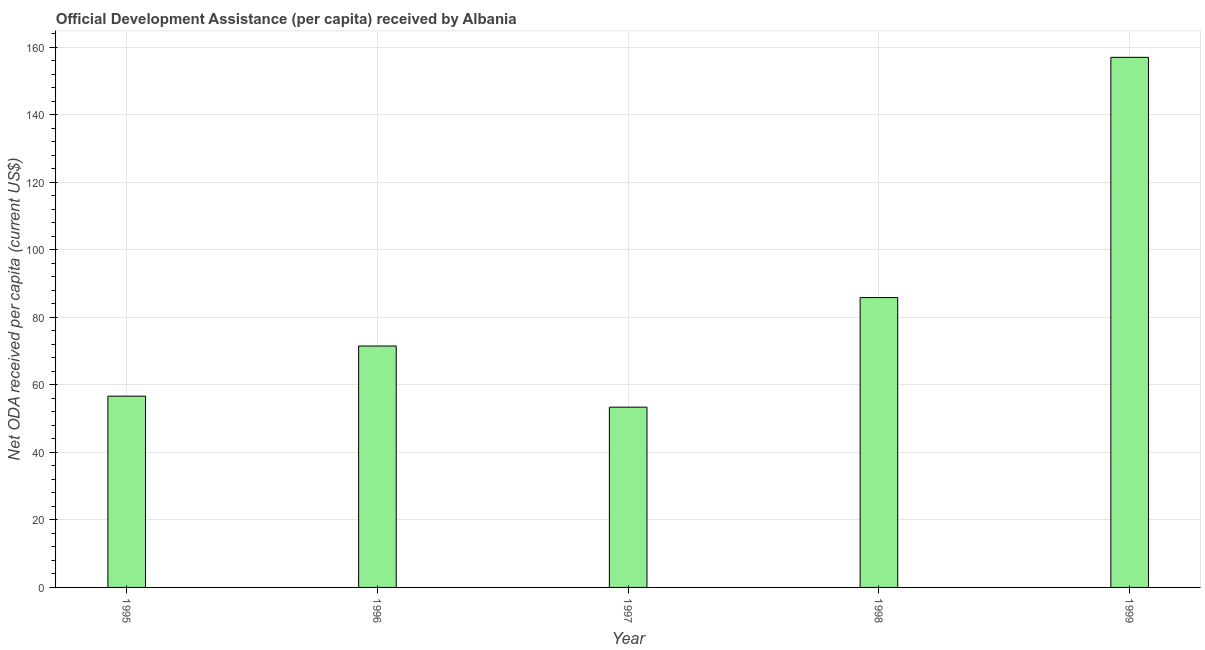Does the graph contain any zero values?
Your answer should be compact. No. Does the graph contain grids?
Your answer should be very brief. Yes. What is the title of the graph?
Provide a short and direct response. Official Development Assistance (per capita) received by Albania. What is the label or title of the X-axis?
Offer a very short reply. Year. What is the label or title of the Y-axis?
Provide a succinct answer. Net ODA received per capita (current US$). What is the net oda received per capita in 1997?
Your answer should be very brief. 53.4. Across all years, what is the maximum net oda received per capita?
Provide a succinct answer. 157.02. Across all years, what is the minimum net oda received per capita?
Keep it short and to the point. 53.4. In which year was the net oda received per capita maximum?
Your answer should be compact. 1999. In which year was the net oda received per capita minimum?
Offer a terse response. 1997. What is the sum of the net oda received per capita?
Give a very brief answer. 424.45. What is the difference between the net oda received per capita in 1995 and 1996?
Offer a terse response. -14.86. What is the average net oda received per capita per year?
Make the answer very short. 84.89. What is the median net oda received per capita?
Your answer should be very brief. 71.51. In how many years, is the net oda received per capita greater than 24 US$?
Offer a very short reply. 5. What is the ratio of the net oda received per capita in 1998 to that in 1999?
Keep it short and to the point. 0.55. Is the net oda received per capita in 1995 less than that in 1997?
Provide a succinct answer. No. What is the difference between the highest and the second highest net oda received per capita?
Give a very brief answer. 71.16. Is the sum of the net oda received per capita in 1995 and 1998 greater than the maximum net oda received per capita across all years?
Your answer should be very brief. No. What is the difference between the highest and the lowest net oda received per capita?
Offer a terse response. 103.63. How many bars are there?
Offer a terse response. 5. How many years are there in the graph?
Your response must be concise. 5. What is the difference between two consecutive major ticks on the Y-axis?
Provide a short and direct response. 20. What is the Net ODA received per capita (current US$) of 1995?
Give a very brief answer. 56.65. What is the Net ODA received per capita (current US$) of 1996?
Make the answer very short. 71.51. What is the Net ODA received per capita (current US$) of 1997?
Your response must be concise. 53.4. What is the Net ODA received per capita (current US$) in 1998?
Offer a terse response. 85.86. What is the Net ODA received per capita (current US$) of 1999?
Offer a terse response. 157.02. What is the difference between the Net ODA received per capita (current US$) in 1995 and 1996?
Ensure brevity in your answer.  -14.86. What is the difference between the Net ODA received per capita (current US$) in 1995 and 1997?
Your response must be concise. 3.26. What is the difference between the Net ODA received per capita (current US$) in 1995 and 1998?
Offer a terse response. -29.21. What is the difference between the Net ODA received per capita (current US$) in 1995 and 1999?
Offer a terse response. -100.37. What is the difference between the Net ODA received per capita (current US$) in 1996 and 1997?
Your response must be concise. 18.11. What is the difference between the Net ODA received per capita (current US$) in 1996 and 1998?
Keep it short and to the point. -14.35. What is the difference between the Net ODA received per capita (current US$) in 1996 and 1999?
Your answer should be compact. -85.51. What is the difference between the Net ODA received per capita (current US$) in 1997 and 1998?
Give a very brief answer. -32.46. What is the difference between the Net ODA received per capita (current US$) in 1997 and 1999?
Offer a terse response. -103.63. What is the difference between the Net ODA received per capita (current US$) in 1998 and 1999?
Keep it short and to the point. -71.16. What is the ratio of the Net ODA received per capita (current US$) in 1995 to that in 1996?
Your answer should be compact. 0.79. What is the ratio of the Net ODA received per capita (current US$) in 1995 to that in 1997?
Your response must be concise. 1.06. What is the ratio of the Net ODA received per capita (current US$) in 1995 to that in 1998?
Provide a succinct answer. 0.66. What is the ratio of the Net ODA received per capita (current US$) in 1995 to that in 1999?
Provide a short and direct response. 0.36. What is the ratio of the Net ODA received per capita (current US$) in 1996 to that in 1997?
Provide a short and direct response. 1.34. What is the ratio of the Net ODA received per capita (current US$) in 1996 to that in 1998?
Provide a succinct answer. 0.83. What is the ratio of the Net ODA received per capita (current US$) in 1996 to that in 1999?
Offer a very short reply. 0.46. What is the ratio of the Net ODA received per capita (current US$) in 1997 to that in 1998?
Keep it short and to the point. 0.62. What is the ratio of the Net ODA received per capita (current US$) in 1997 to that in 1999?
Provide a short and direct response. 0.34. What is the ratio of the Net ODA received per capita (current US$) in 1998 to that in 1999?
Your response must be concise. 0.55. 